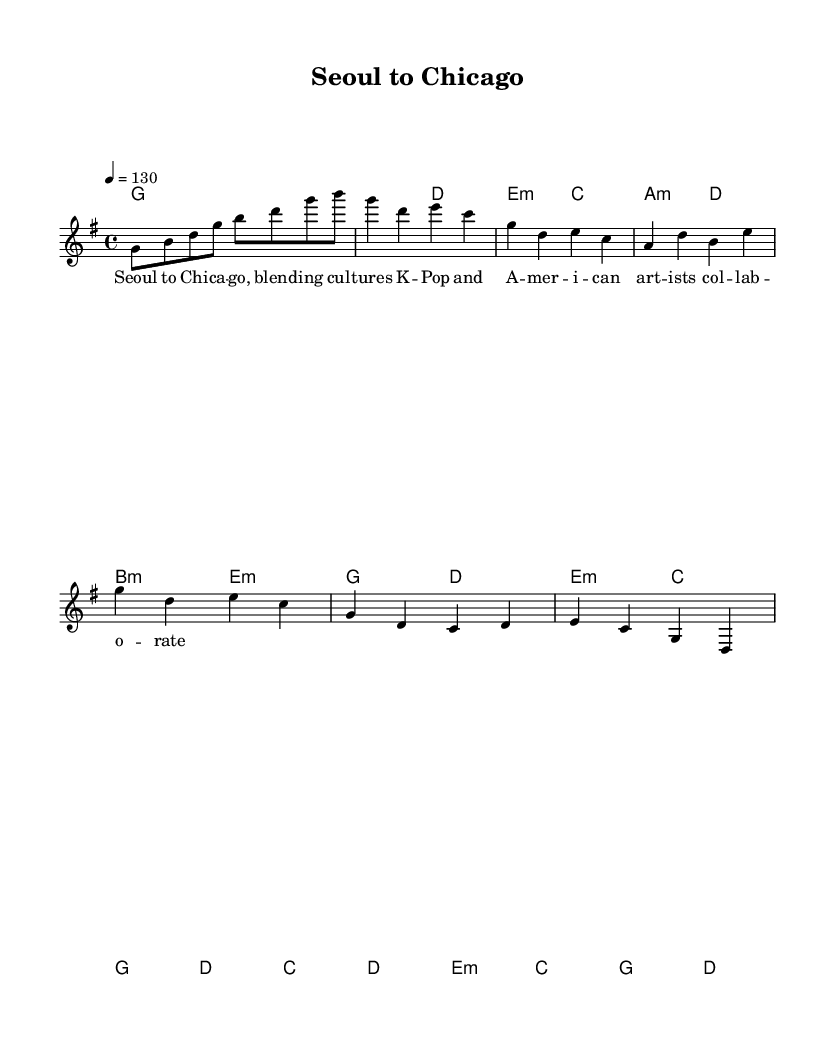What is the key signature of this music? The key signature is G major, which has one sharp (F#). This can be determined by looking at the key signature indicated at the beginning of the piece.
Answer: G major What is the time signature for this music piece? The time signature is 4/4, which can be seen at the beginning of the score. This means there are four beats in a measure and the quarter note gets one beat.
Answer: 4/4 What is the tempo marking in this sheet music? The tempo marking is 130 beats per minute, indicated by the phrase "4 = 130" at the start of the music. This means that a quarter note is to be played at 130 beats per minute.
Answer: 130 How many measures are in the verse section? The verse section consists of 2 measures, which can be counted from the melody line where the notes are written. Each unique grouping of notes separated by vertical lines represents one measure.
Answer: 2 What chord appears in the pre-chorus? The chords in the pre-chorus are A minor, D major, B minor, and E minor. By analyzing the chord changes during this section, I can identify these chords.
Answer: A minor, D major, B minor, E minor What is the lyrical theme of this piece? The lyrics express the blending of cultures between K-Pop and American artists, suggesting collaboration and influence between different musical styles. This can be gleaned from the lyrics themselves.
Answer: Blending cultures What unique musical structure can be identified in K-Pop songs compared to Western pop? K-Pop songs often feature a strong emphasis on catchy choruses and a mix of rap and melodic vocals, which is common in this piece's repetitive chorus and rhythmic variations reflected in the melody.
Answer: Catchy choruses and rap 